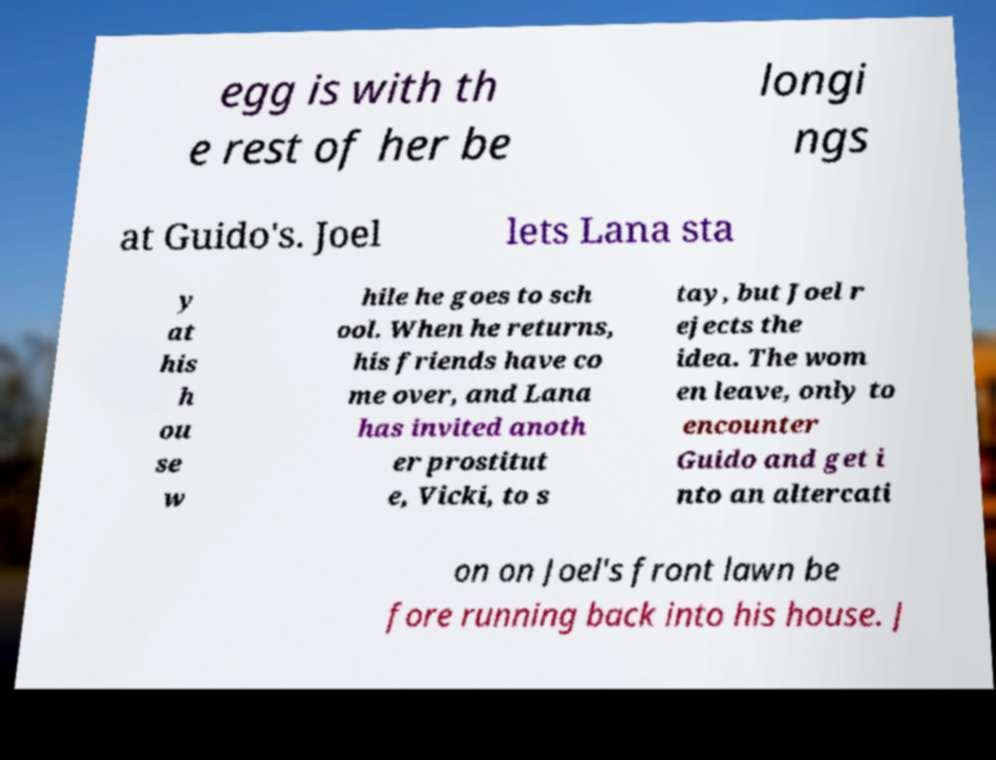I need the written content from this picture converted into text. Can you do that? egg is with th e rest of her be longi ngs at Guido's. Joel lets Lana sta y at his h ou se w hile he goes to sch ool. When he returns, his friends have co me over, and Lana has invited anoth er prostitut e, Vicki, to s tay, but Joel r ejects the idea. The wom en leave, only to encounter Guido and get i nto an altercati on on Joel's front lawn be fore running back into his house. J 